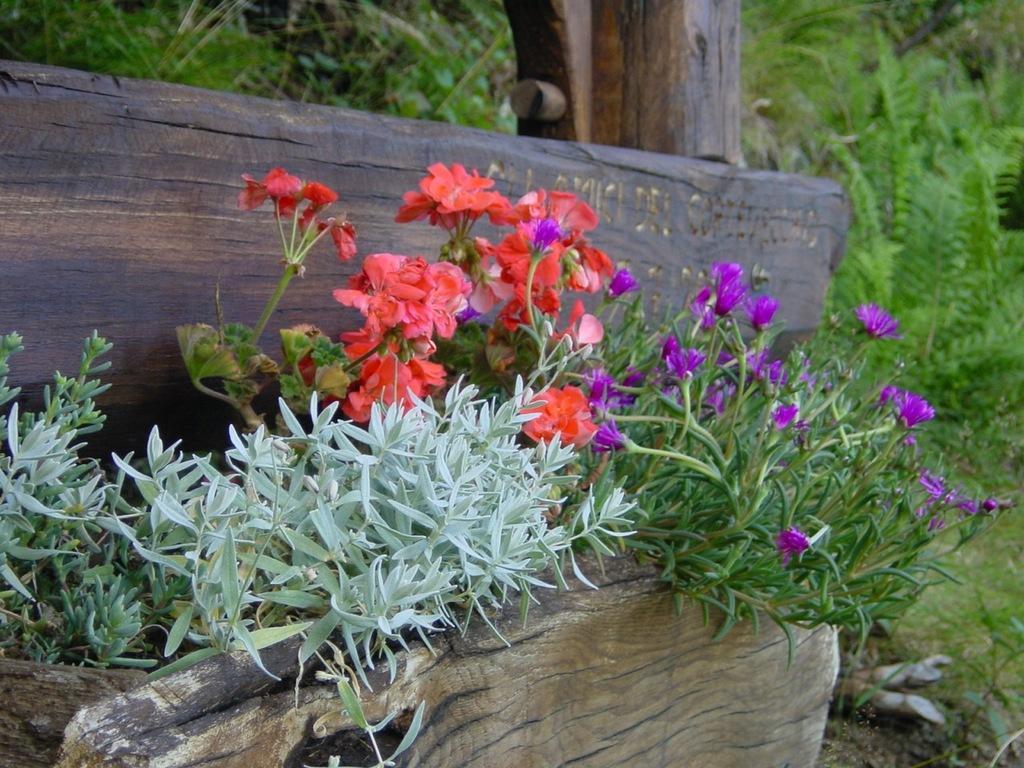Describe this image in one or two sentences. In this image there are plants and we can see flowers. In the background there are trees and we can see wooden logs. 